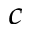Convert formula to latex. <formula><loc_0><loc_0><loc_500><loc_500>^ { c }</formula> 